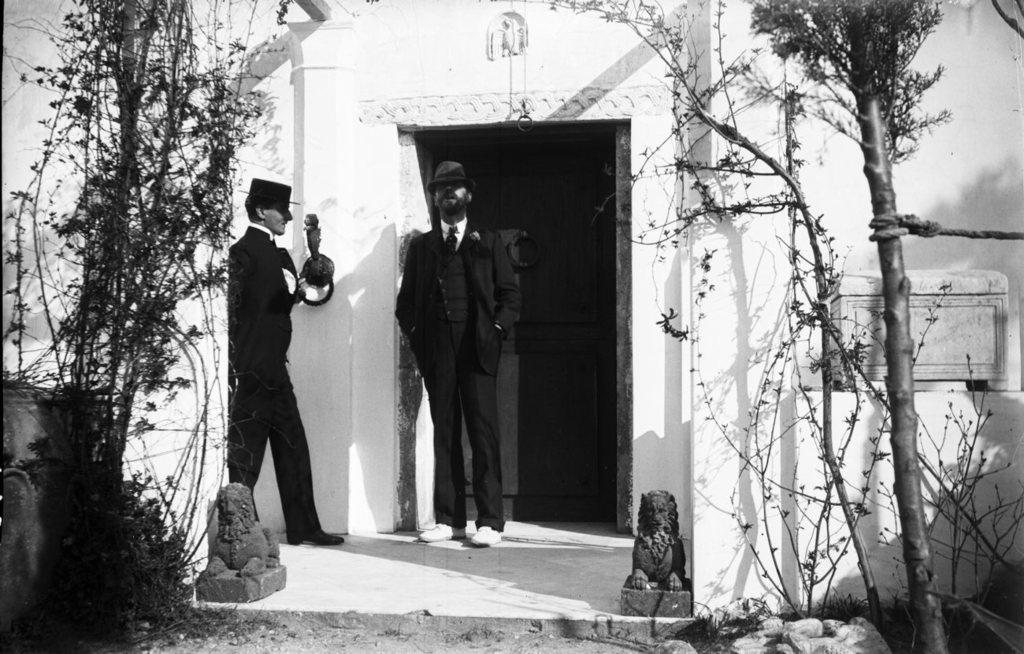What is the color scheme of the image? The image is black and white. How many people are present in the image? There are two persons standing in the image. What type of structure can be seen in the image? There is a house in the image. What type of natural elements are present in the image? There are trees and plants in the image. What type of artwork is visible in the image? There are sculptures in the image. In which direction are the cows facing in the image? There are no cows present in the image. What type of arithmetic problem can be solved using the numbers on the sculptures in the image? There is no arithmetic problem present in the image, as the sculptures do not have numbers. 